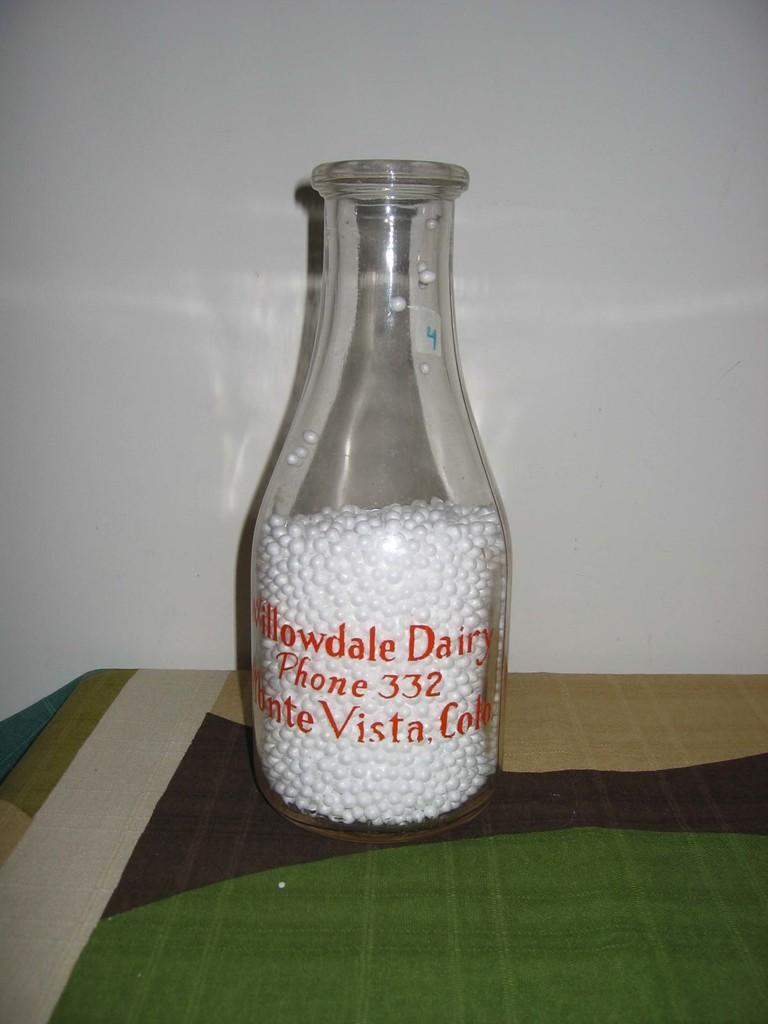<image>
Create a compact narrative representing the image presented. An old glass jar with white beads in it has Willowdale  Dairy written in red. 